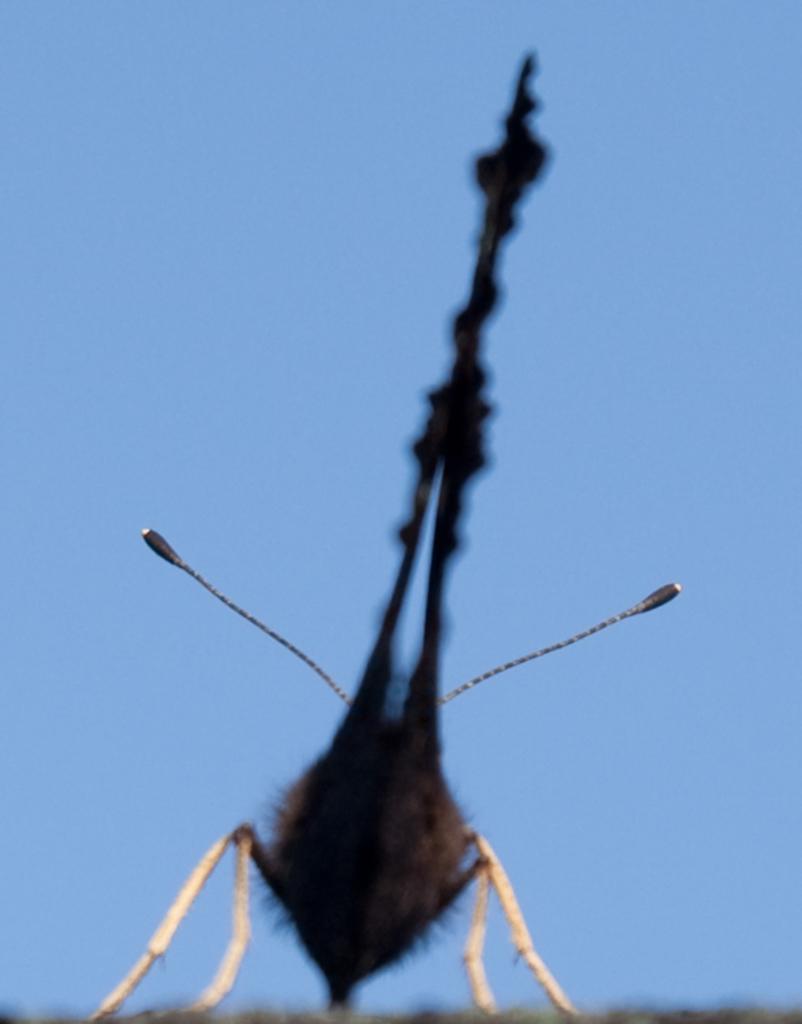In one or two sentences, can you explain what this image depicts? In the foreground of this image, there is an insect. In the background, there is the sky. 